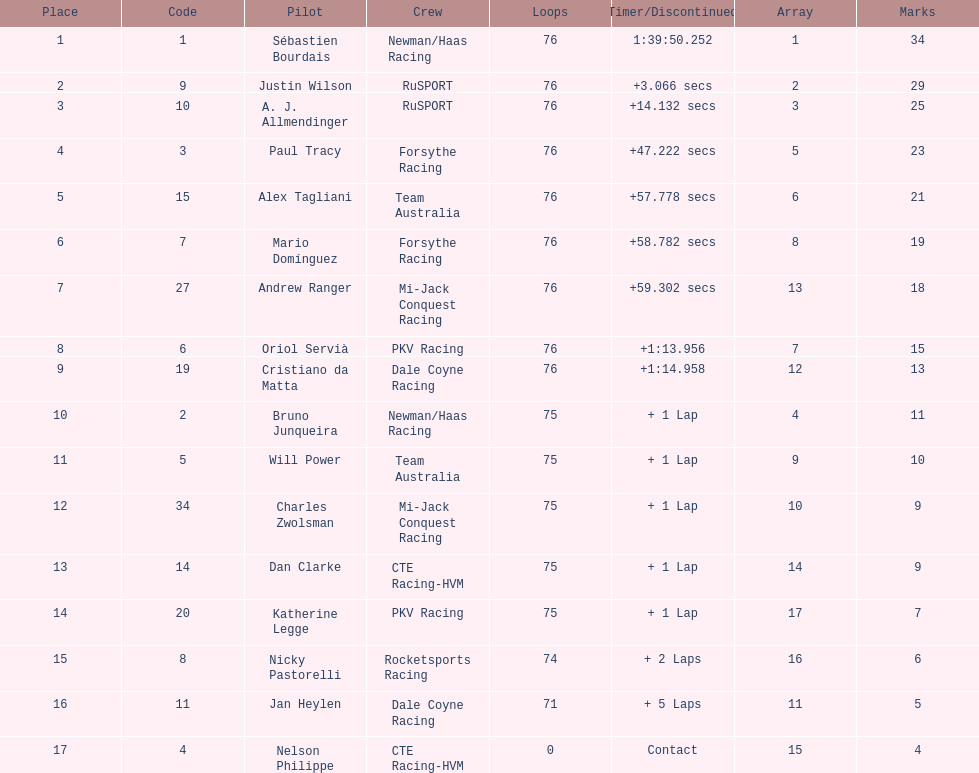How many positions are held by canada? 3. 